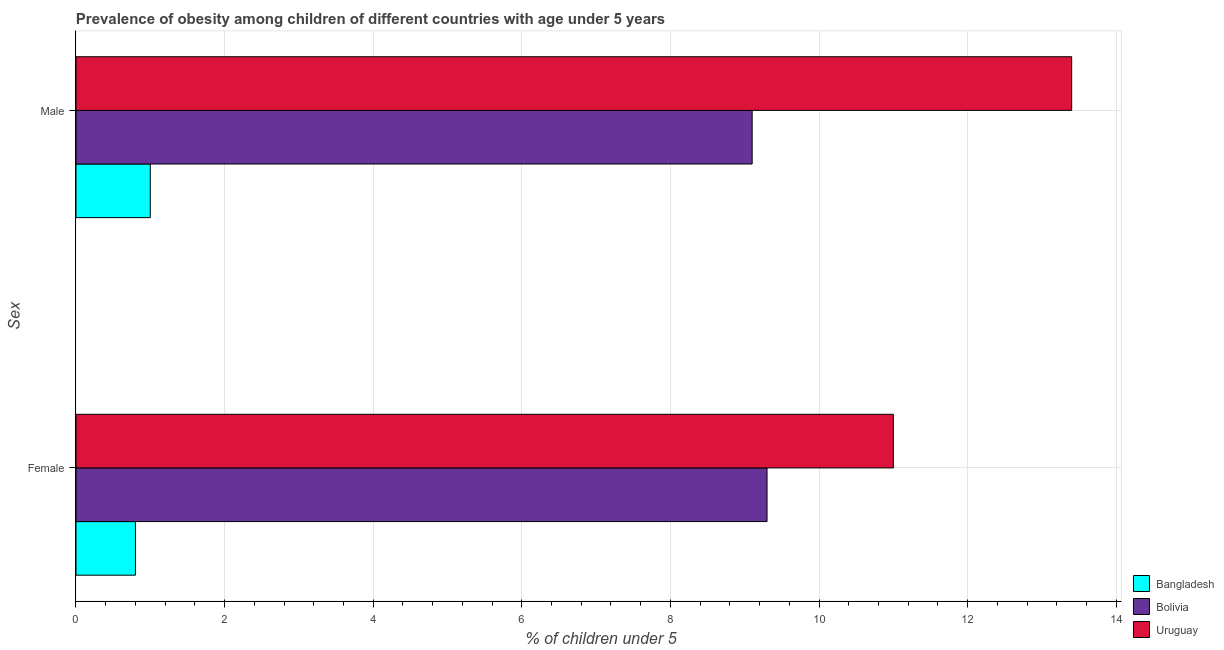How many different coloured bars are there?
Your answer should be compact. 3. How many groups of bars are there?
Make the answer very short. 2. What is the percentage of obese male children in Uruguay?
Your answer should be very brief. 13.4. Across all countries, what is the maximum percentage of obese male children?
Offer a terse response. 13.4. Across all countries, what is the minimum percentage of obese female children?
Make the answer very short. 0.8. In which country was the percentage of obese female children maximum?
Offer a very short reply. Uruguay. What is the total percentage of obese male children in the graph?
Your answer should be very brief. 23.5. What is the difference between the percentage of obese male children in Uruguay and that in Bolivia?
Give a very brief answer. 4.3. What is the difference between the percentage of obese male children in Uruguay and the percentage of obese female children in Bolivia?
Offer a very short reply. 4.1. What is the average percentage of obese female children per country?
Provide a short and direct response. 7.03. What is the difference between the percentage of obese female children and percentage of obese male children in Bolivia?
Your response must be concise. 0.2. In how many countries, is the percentage of obese female children greater than 9.6 %?
Your answer should be compact. 1. What is the ratio of the percentage of obese male children in Bolivia to that in Uruguay?
Provide a short and direct response. 0.68. What does the 1st bar from the top in Female represents?
Your response must be concise. Uruguay. How many bars are there?
Keep it short and to the point. 6. How many countries are there in the graph?
Give a very brief answer. 3. Does the graph contain any zero values?
Provide a succinct answer. No. Where does the legend appear in the graph?
Ensure brevity in your answer.  Bottom right. How many legend labels are there?
Give a very brief answer. 3. What is the title of the graph?
Offer a terse response. Prevalence of obesity among children of different countries with age under 5 years. Does "Vietnam" appear as one of the legend labels in the graph?
Make the answer very short. No. What is the label or title of the X-axis?
Make the answer very short.  % of children under 5. What is the label or title of the Y-axis?
Provide a succinct answer. Sex. What is the  % of children under 5 in Bangladesh in Female?
Your response must be concise. 0.8. What is the  % of children under 5 in Bolivia in Female?
Provide a succinct answer. 9.3. What is the  % of children under 5 in Uruguay in Female?
Provide a short and direct response. 11. What is the  % of children under 5 of Bangladesh in Male?
Offer a very short reply. 1. What is the  % of children under 5 in Bolivia in Male?
Your answer should be compact. 9.1. What is the  % of children under 5 in Uruguay in Male?
Your answer should be compact. 13.4. Across all Sex, what is the maximum  % of children under 5 in Bolivia?
Your response must be concise. 9.3. Across all Sex, what is the maximum  % of children under 5 in Uruguay?
Provide a short and direct response. 13.4. Across all Sex, what is the minimum  % of children under 5 in Bangladesh?
Your answer should be compact. 0.8. Across all Sex, what is the minimum  % of children under 5 in Bolivia?
Ensure brevity in your answer.  9.1. Across all Sex, what is the minimum  % of children under 5 in Uruguay?
Your response must be concise. 11. What is the total  % of children under 5 in Bangladesh in the graph?
Keep it short and to the point. 1.8. What is the total  % of children under 5 of Uruguay in the graph?
Provide a short and direct response. 24.4. What is the difference between the  % of children under 5 of Uruguay in Female and that in Male?
Your answer should be very brief. -2.4. What is the difference between the  % of children under 5 of Bangladesh in Female and the  % of children under 5 of Bolivia in Male?
Your answer should be very brief. -8.3. What is the difference between the  % of children under 5 in Bangladesh in Female and the  % of children under 5 in Uruguay in Male?
Ensure brevity in your answer.  -12.6. What is the average  % of children under 5 of Bangladesh per Sex?
Your answer should be compact. 0.9. What is the average  % of children under 5 in Bolivia per Sex?
Provide a short and direct response. 9.2. What is the difference between the  % of children under 5 of Bolivia and  % of children under 5 of Uruguay in Female?
Give a very brief answer. -1.7. What is the difference between the  % of children under 5 of Bolivia and  % of children under 5 of Uruguay in Male?
Offer a very short reply. -4.3. What is the ratio of the  % of children under 5 in Bolivia in Female to that in Male?
Keep it short and to the point. 1.02. What is the ratio of the  % of children under 5 in Uruguay in Female to that in Male?
Your answer should be very brief. 0.82. What is the difference between the highest and the second highest  % of children under 5 of Bangladesh?
Keep it short and to the point. 0.2. What is the difference between the highest and the second highest  % of children under 5 in Uruguay?
Your response must be concise. 2.4. 